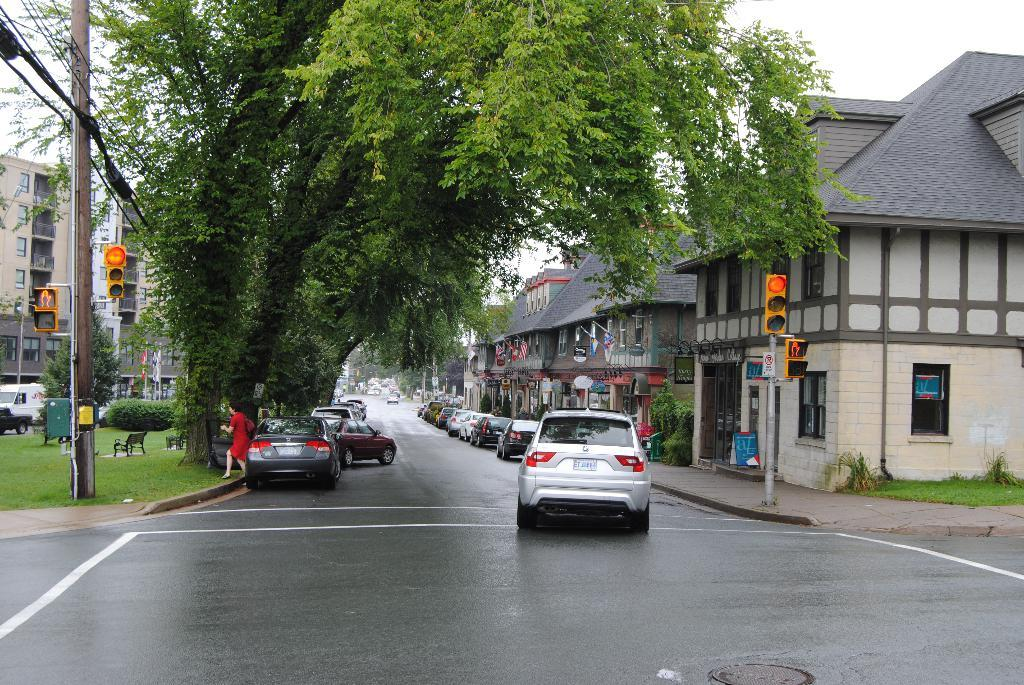What type of structures can be seen in the image? There are buildings in the image. What traffic control devices are present in the image? There are traffic lights in the image. What type of vegetation is visible in the image? There is grass, plants, creepers, trees, and bushes in the image. What type of seating is available in the image? There are benches in the image. What type of infrastructure is present in the image? There are electric poles and electric cables in the image. What type of transportation is visible in the image? There are motor vehicles in the image. Is there a person present in the image? Yes, there is a woman in the image. What part of the natural environment is visible in the image? The sky is visible in the image. What type of news can be heard coming from the electric poles in the image? There is no indication in the image that the electric poles are broadcasting news or any other sounds. 